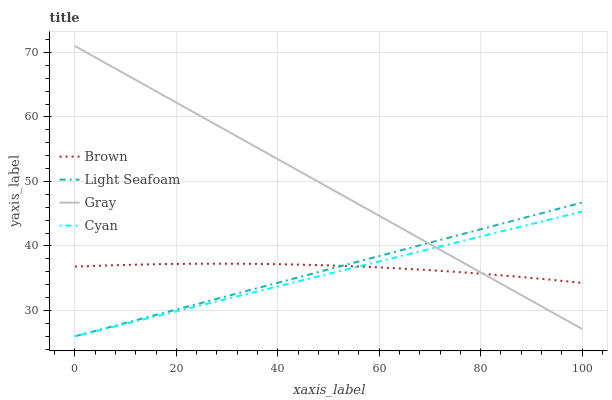Does Cyan have the minimum area under the curve?
Answer yes or no. Yes. Does Gray have the maximum area under the curve?
Answer yes or no. Yes. Does Light Seafoam have the minimum area under the curve?
Answer yes or no. No. Does Light Seafoam have the maximum area under the curve?
Answer yes or no. No. Is Light Seafoam the smoothest?
Answer yes or no. Yes. Is Brown the roughest?
Answer yes or no. Yes. Is Cyan the smoothest?
Answer yes or no. No. Is Cyan the roughest?
Answer yes or no. No. Does Cyan have the lowest value?
Answer yes or no. Yes. Does Gray have the lowest value?
Answer yes or no. No. Does Gray have the highest value?
Answer yes or no. Yes. Does Cyan have the highest value?
Answer yes or no. No. Does Brown intersect Cyan?
Answer yes or no. Yes. Is Brown less than Cyan?
Answer yes or no. No. Is Brown greater than Cyan?
Answer yes or no. No. 